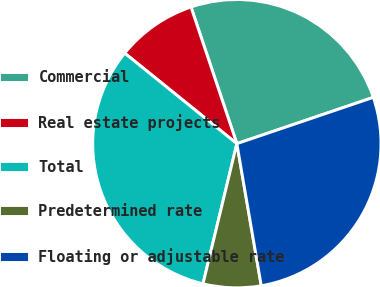<chart> <loc_0><loc_0><loc_500><loc_500><pie_chart><fcel>Commercial<fcel>Real estate projects<fcel>Total<fcel>Predetermined rate<fcel>Floating or adjustable rate<nl><fcel>24.95%<fcel>9.04%<fcel>32.04%<fcel>6.48%<fcel>27.5%<nl></chart> 